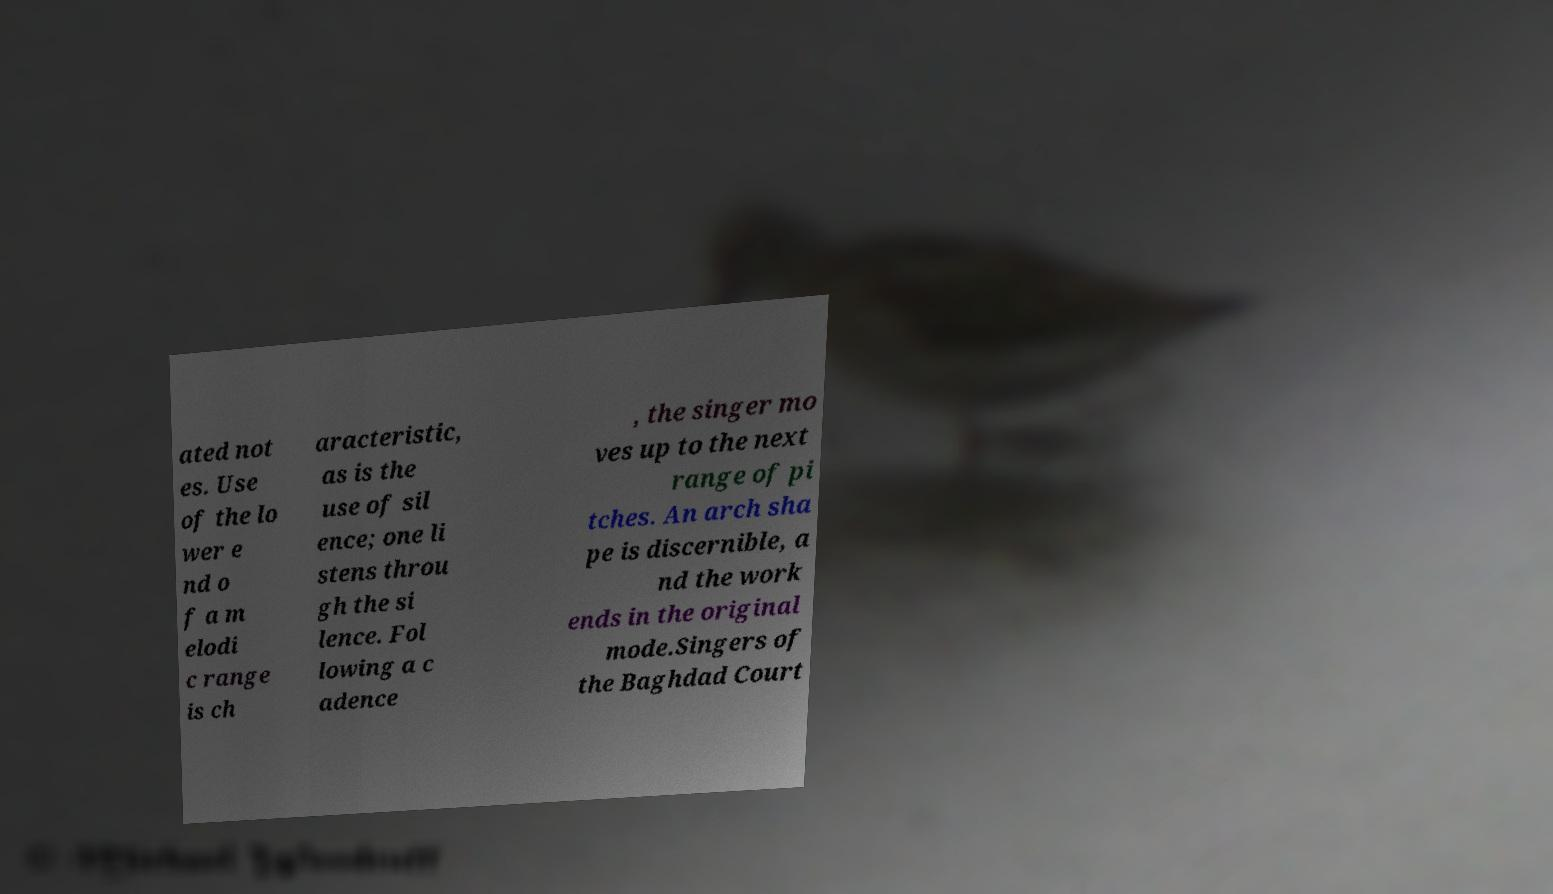Please identify and transcribe the text found in this image. ated not es. Use of the lo wer e nd o f a m elodi c range is ch aracteristic, as is the use of sil ence; one li stens throu gh the si lence. Fol lowing a c adence , the singer mo ves up to the next range of pi tches. An arch sha pe is discernible, a nd the work ends in the original mode.Singers of the Baghdad Court 